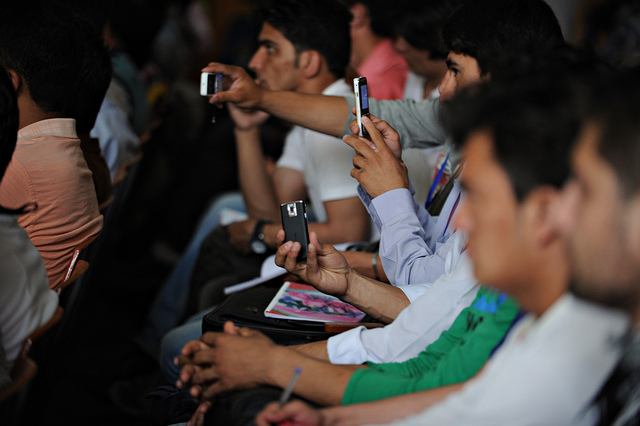<image>What is the man in the red and white cap doing? I don't know what the man in the red and white cap is doing as he is not pictured in the image. What is the man in the red and white cap doing? I don't know what the man in the red and white cap is doing. 